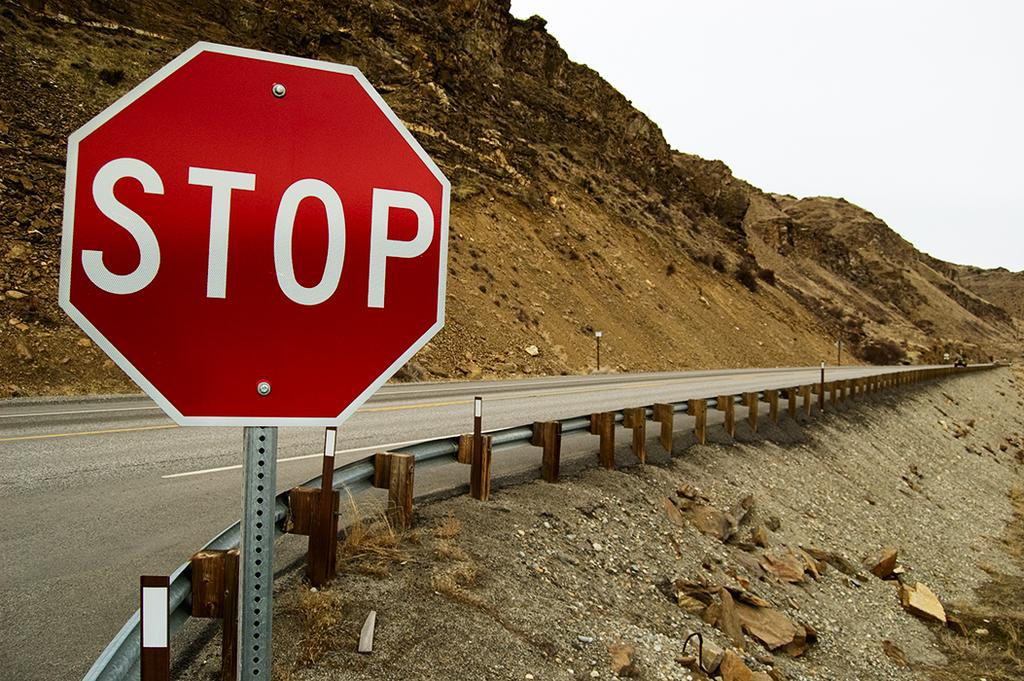<image>
Give a short and clear explanation of the subsequent image. A red sign on the side of a highway along a mountain says Stop. 